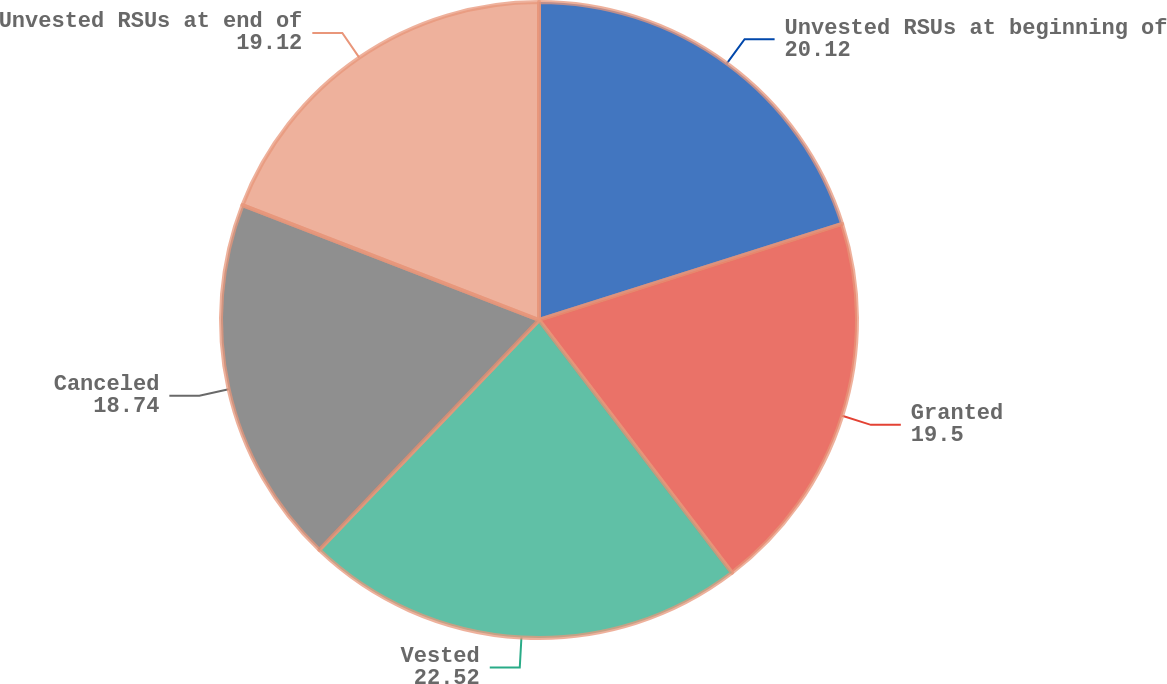<chart> <loc_0><loc_0><loc_500><loc_500><pie_chart><fcel>Unvested RSUs at beginning of<fcel>Granted<fcel>Vested<fcel>Canceled<fcel>Unvested RSUs at end of<nl><fcel>20.12%<fcel>19.5%<fcel>22.52%<fcel>18.74%<fcel>19.12%<nl></chart> 